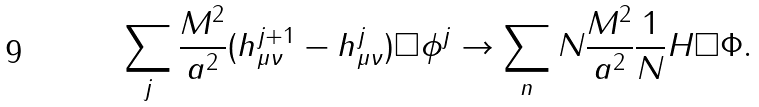<formula> <loc_0><loc_0><loc_500><loc_500>\sum _ { j } \frac { M ^ { 2 } } { a ^ { 2 } } ( h _ { \mu \nu } ^ { j + 1 } - h _ { \mu \nu } ^ { j } ) \Box \phi ^ { j } \rightarrow \sum _ { n } N \frac { M ^ { 2 } } { a ^ { 2 } } \frac { 1 } { N } H \Box \Phi .</formula> 